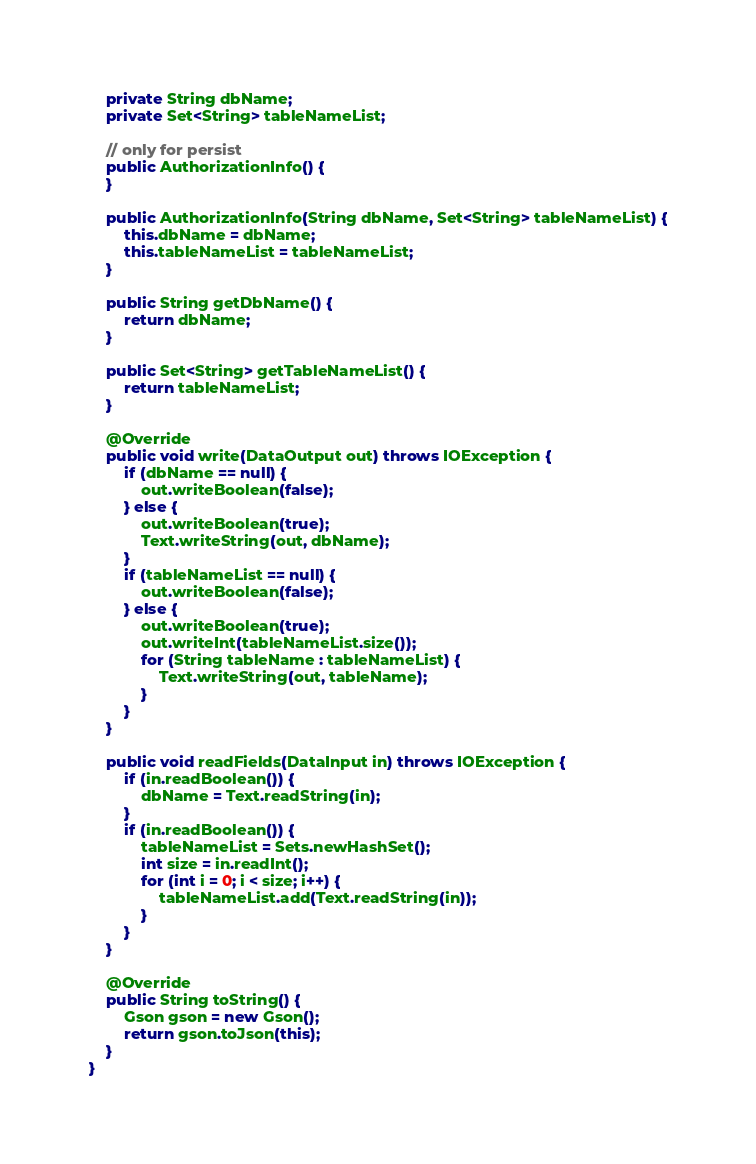<code> <loc_0><loc_0><loc_500><loc_500><_Java_>    private String dbName;
    private Set<String> tableNameList;

    // only for persist
    public AuthorizationInfo() {
    }

    public AuthorizationInfo(String dbName, Set<String> tableNameList) {
        this.dbName = dbName;
        this.tableNameList = tableNameList;
    }

    public String getDbName() {
        return dbName;
    }

    public Set<String> getTableNameList() {
        return tableNameList;
    }

    @Override
    public void write(DataOutput out) throws IOException {
        if (dbName == null) {
            out.writeBoolean(false);
        } else {
            out.writeBoolean(true);
            Text.writeString(out, dbName);
        }
        if (tableNameList == null) {
            out.writeBoolean(false);
        } else {
            out.writeBoolean(true);
            out.writeInt(tableNameList.size());
            for (String tableName : tableNameList) {
                Text.writeString(out, tableName);
            }
        }
    }

    public void readFields(DataInput in) throws IOException {
        if (in.readBoolean()) {
            dbName = Text.readString(in);
        }
        if (in.readBoolean()) {
            tableNameList = Sets.newHashSet();
            int size = in.readInt();
            for (int i = 0; i < size; i++) {
                tableNameList.add(Text.readString(in));
            }
        }
    }

    @Override
    public String toString() {
        Gson gson = new Gson();
        return gson.toJson(this);
    }
}
</code> 